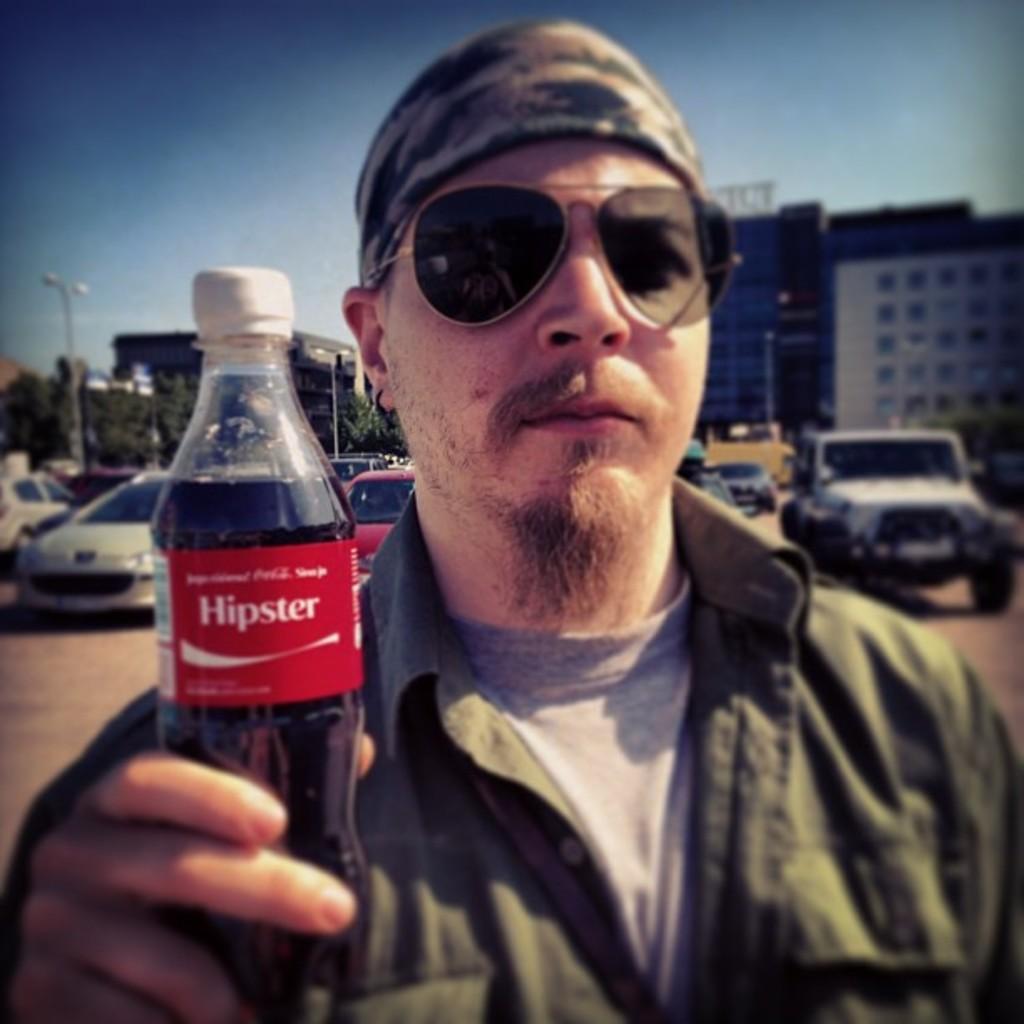Could you give a brief overview of what you see in this image? Here we can see a man standing and holding a bottle in his hands, and at back here are the cars, and here is the building, and at above here is the sky. 